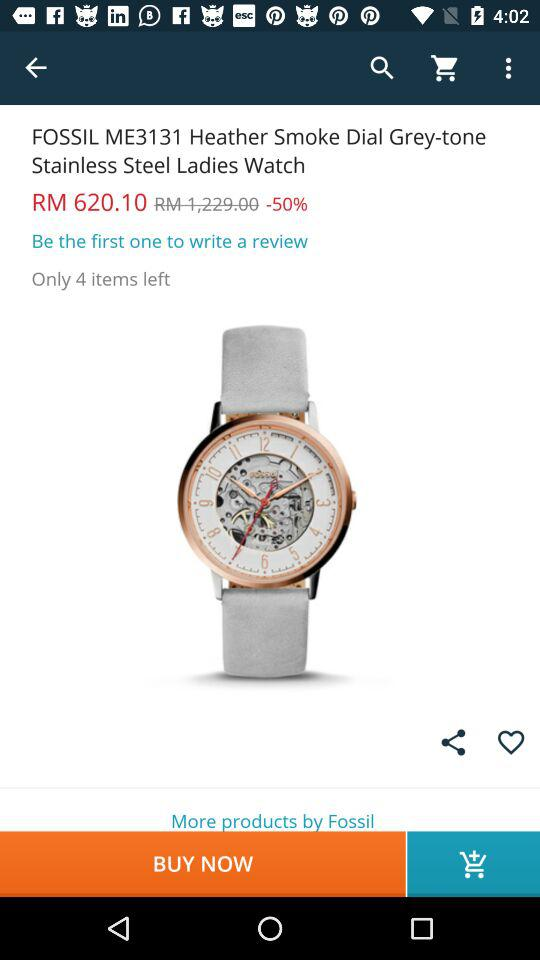How much is the discount on "Fossil ME3131"? There is a 50% discount on "Fossil ME3131". 